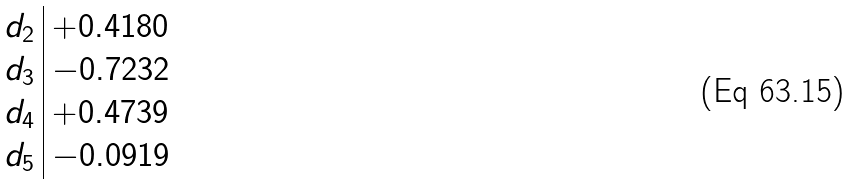<formula> <loc_0><loc_0><loc_500><loc_500>\begin{array} { c | l } d _ { 2 } & + 0 . 4 1 8 0 \\ d _ { 3 } & - 0 . 7 2 3 2 \\ d _ { 4 } & + 0 . 4 7 3 9 \\ d _ { 5 } & - 0 . 0 9 1 9 \\ \end{array}</formula> 